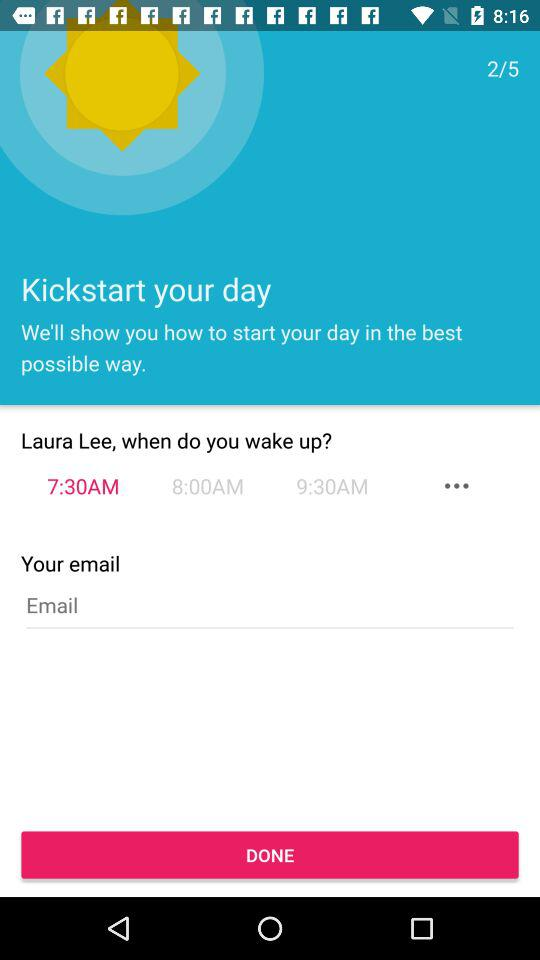Which time has been chosen to wake up? The chosen time to wake up is 7:30 AM. 